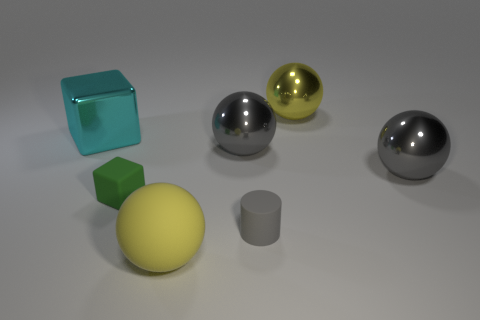There is another sphere that is the same color as the rubber ball; what is it made of?
Your answer should be very brief. Metal. What is the size of the thing that is the same color as the big rubber ball?
Ensure brevity in your answer.  Large. Do the small cylinder and the big shiny block have the same color?
Provide a short and direct response. No. Is the number of rubber cylinders that are behind the gray rubber cylinder less than the number of small matte cubes in front of the green matte object?
Offer a terse response. No. What shape is the yellow thing that is the same material as the small gray cylinder?
Give a very brief answer. Sphere. Are there any other things that are the same color as the tiny rubber cylinder?
Your response must be concise. Yes. What is the color of the big metallic ball behind the metallic object left of the yellow rubber object?
Ensure brevity in your answer.  Yellow. What is the material of the large yellow sphere behind the green rubber object left of the big yellow thing left of the gray matte object?
Make the answer very short. Metal. How many gray matte cylinders are the same size as the green thing?
Your response must be concise. 1. What is the material of the thing that is to the left of the yellow rubber object and behind the green matte cube?
Your answer should be compact. Metal. 